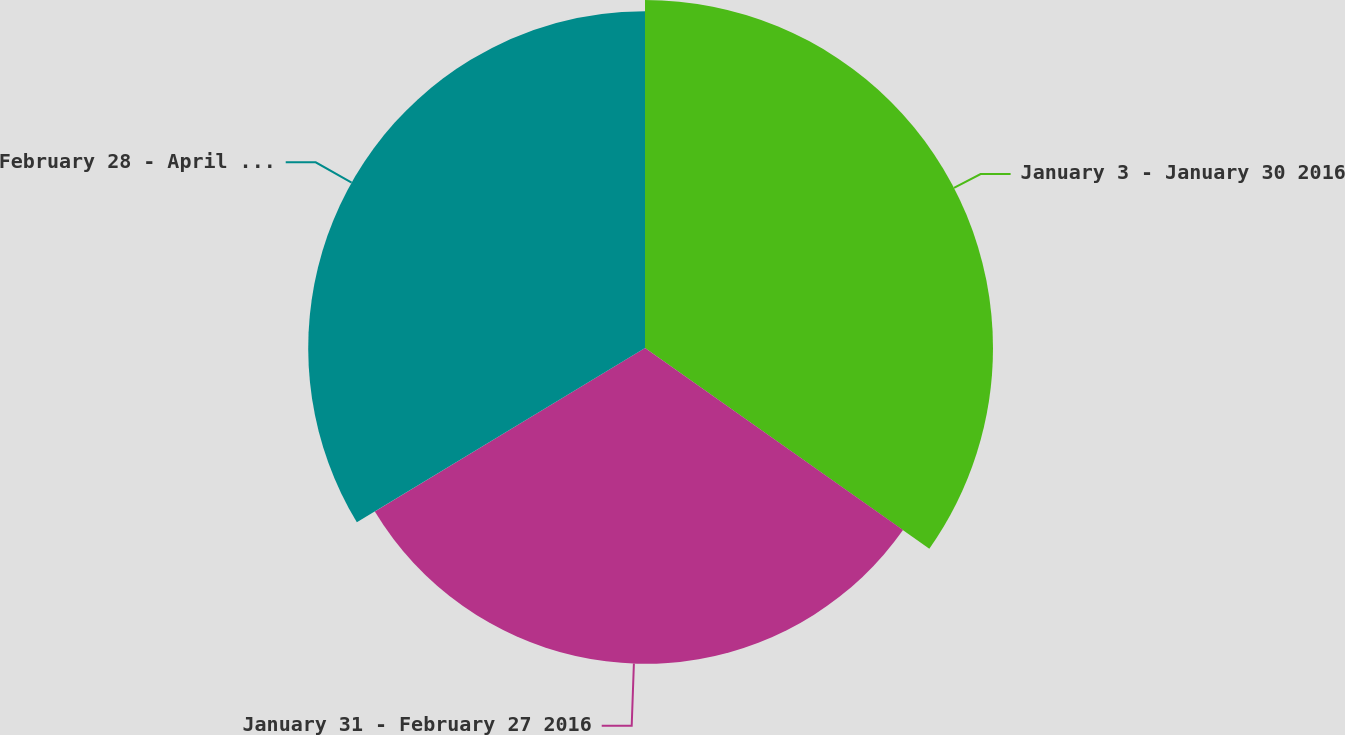<chart> <loc_0><loc_0><loc_500><loc_500><pie_chart><fcel>January 3 - January 30 2016<fcel>January 31 - February 27 2016<fcel>February 28 - April 2 2016<nl><fcel>34.78%<fcel>31.56%<fcel>33.66%<nl></chart> 